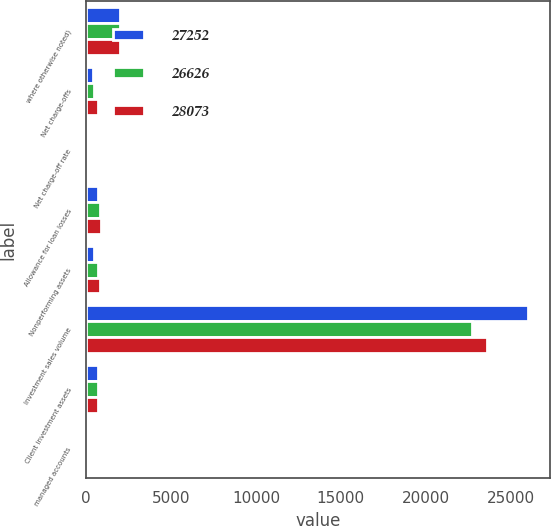Convert chart to OTSL. <chart><loc_0><loc_0><loc_500><loc_500><stacked_bar_chart><ecel><fcel>where otherwise noted)<fcel>Net charge-offs<fcel>Net charge-off rate<fcel>Allowance for loan losses<fcel>Nonperforming assets<fcel>Investment sales volume<fcel>Client investment assets<fcel>managed accounts<nl><fcel>27252<fcel>2012<fcel>411<fcel>2.27<fcel>698<fcel>488<fcel>26036<fcel>710<fcel>29<nl><fcel>26626<fcel>2011<fcel>494<fcel>2.89<fcel>798<fcel>710<fcel>22716<fcel>710<fcel>24<nl><fcel>28073<fcel>2010<fcel>730<fcel>4.32<fcel>875<fcel>846<fcel>23579<fcel>710<fcel>20<nl></chart> 